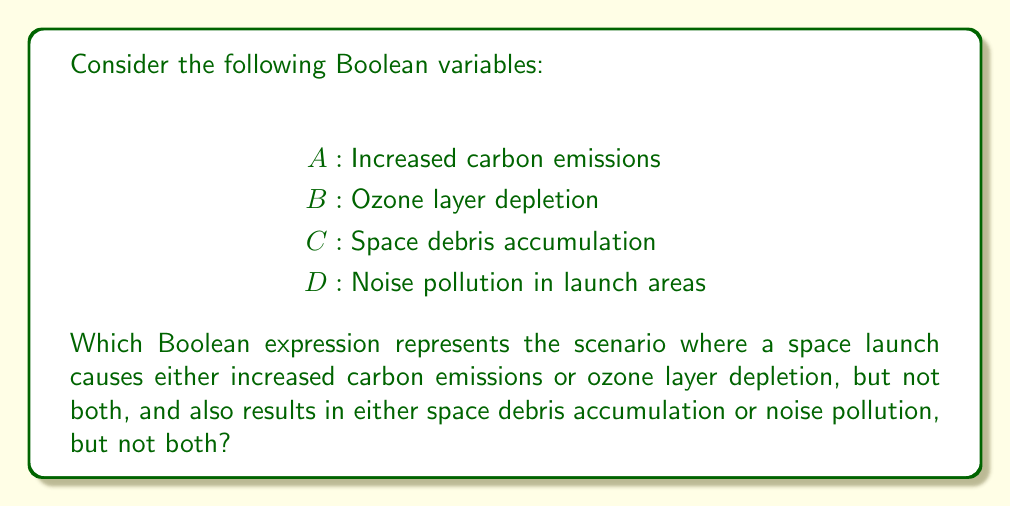Solve this math problem. To solve this problem, we need to break it down into two parts and then combine them:

1. "Either increased carbon emissions or ozone layer depletion, but not both":
   This is represented by the XOR operation, which we can write as $A \oplus B$

2. "Either space debris accumulation or noise pollution, but not both":
   This is also represented by the XOR operation: $C \oplus D$

3. We want both of these conditions to be true, so we need to use the AND operation to combine them.

The resulting Boolean expression is:

$$(A \oplus B) \land (C \oplus D)$$

To expand this further:

$$(A \oplus B) = (A \lor B) \land (\lnot A \lor \lnot B)$$
$$(C \oplus D) = (C \lor D) \land (\lnot C \lor \lnot D)$$

So the full expanded expression would be:

$$((A \lor B) \land (\lnot A \lor \lnot B)) \land ((C \lor D) \land (\lnot C \lor \lnot D))$$

This expression will be true only when exactly one of $A$ or $B$ is true, and exactly one of $C$ or $D$ is true.
Answer: $(A \oplus B) \land (C \oplus D)$ 